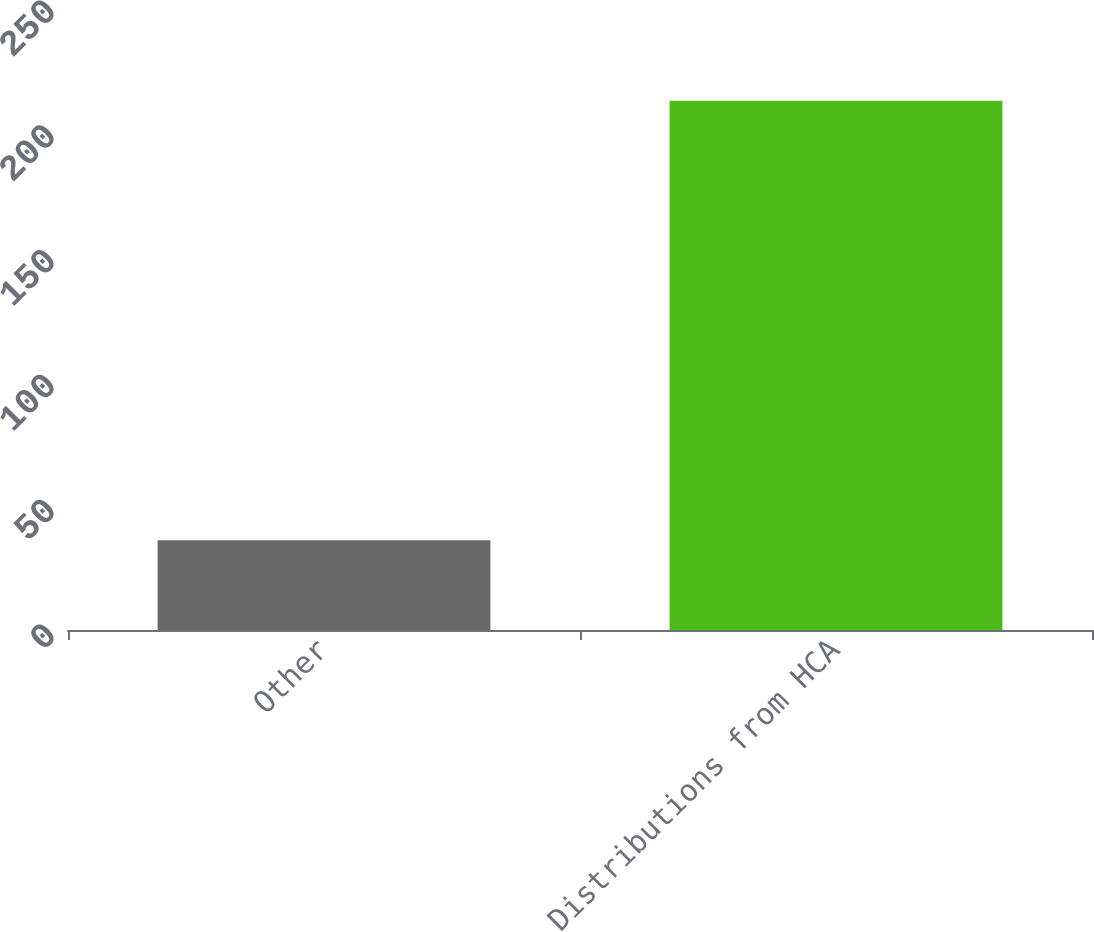Convert chart to OTSL. <chart><loc_0><loc_0><loc_500><loc_500><bar_chart><fcel>Other<fcel>Distributions from HCA<nl><fcel>36<fcel>212<nl></chart> 